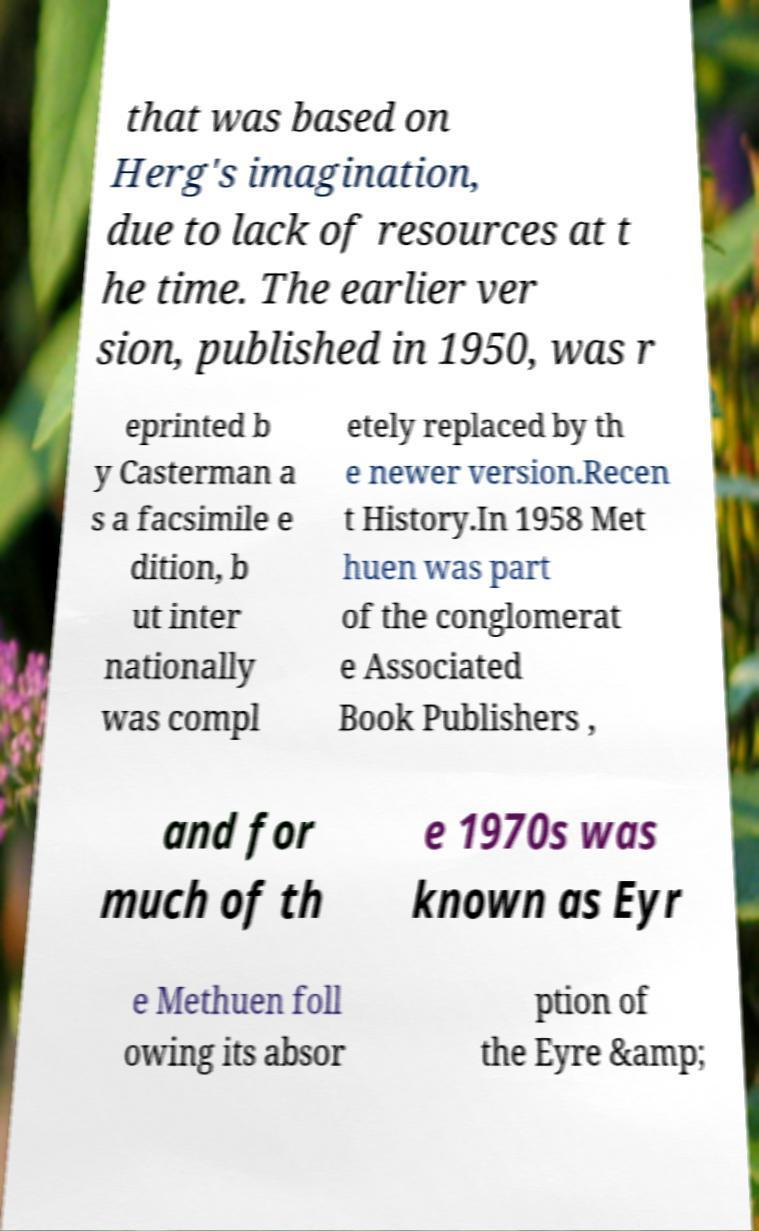What messages or text are displayed in this image? I need them in a readable, typed format. that was based on Herg's imagination, due to lack of resources at t he time. The earlier ver sion, published in 1950, was r eprinted b y Casterman a s a facsimile e dition, b ut inter nationally was compl etely replaced by th e newer version.Recen t History.In 1958 Met huen was part of the conglomerat e Associated Book Publishers , and for much of th e 1970s was known as Eyr e Methuen foll owing its absor ption of the Eyre &amp; 